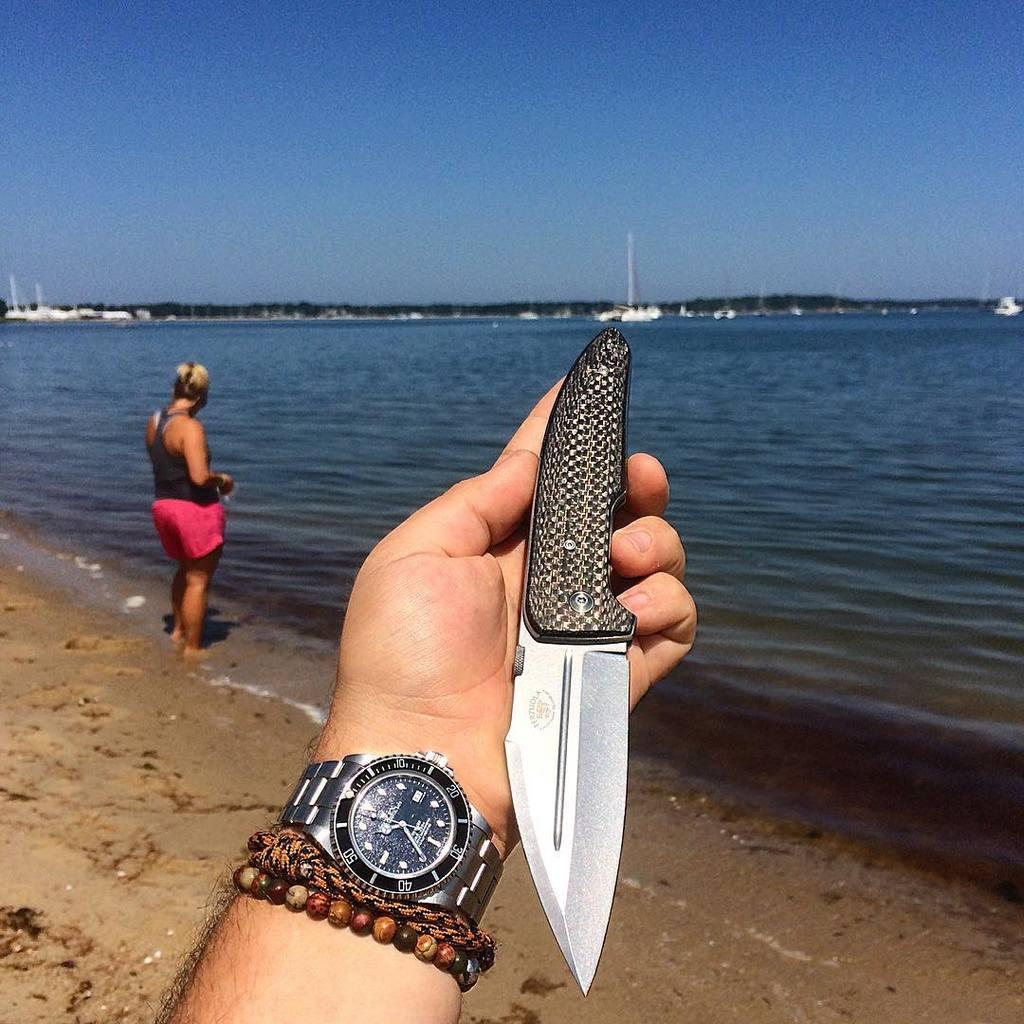Provide a one-sentence caption for the provided image. The time is 10:35 on a man's watch and he holds a knife in his hand on a beach. 